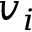Convert formula to latex. <formula><loc_0><loc_0><loc_500><loc_500>v _ { i }</formula> 